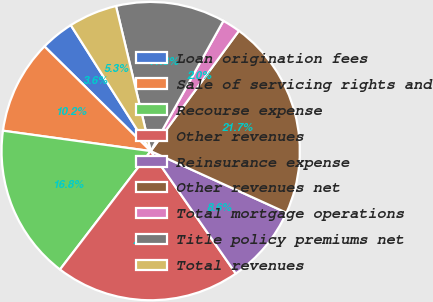<chart> <loc_0><loc_0><loc_500><loc_500><pie_chart><fcel>Loan origination fees<fcel>Sale of servicing rights and<fcel>Recourse expense<fcel>Other revenues<fcel>Reinsurance expense<fcel>Other revenues net<fcel>Total mortgage operations<fcel>Title policy premiums net<fcel>Total revenues<nl><fcel>3.62%<fcel>10.2%<fcel>16.78%<fcel>20.07%<fcel>8.55%<fcel>21.71%<fcel>1.97%<fcel>11.84%<fcel>5.26%<nl></chart> 